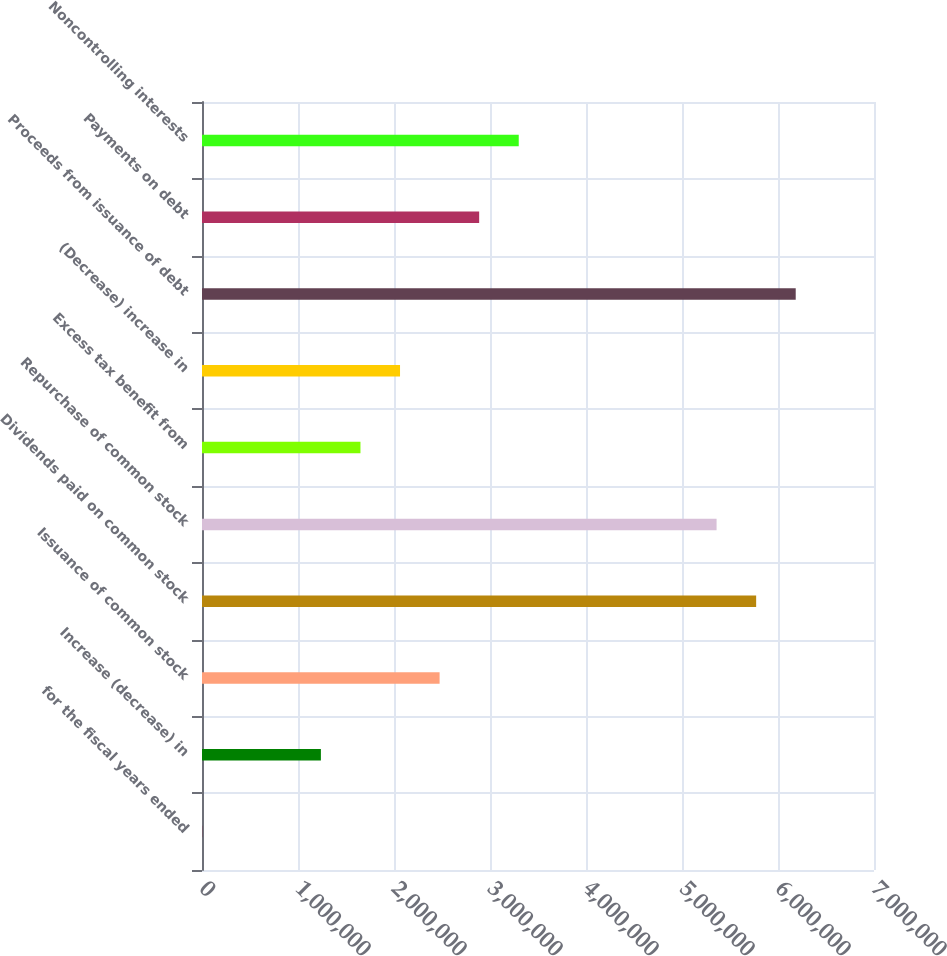<chart> <loc_0><loc_0><loc_500><loc_500><bar_chart><fcel>for the fiscal years ended<fcel>Increase (decrease) in<fcel>Issuance of common stock<fcel>Dividends paid on common stock<fcel>Repurchase of common stock<fcel>Excess tax benefit from<fcel>(Decrease) increase in<fcel>Proceeds from issuance of debt<fcel>Payments on debt<fcel>Noncontrolling interests<nl><fcel>2010<fcel>1.23852e+06<fcel>2.47503e+06<fcel>5.7724e+06<fcel>5.36023e+06<fcel>1.65069e+06<fcel>2.06286e+06<fcel>6.18457e+06<fcel>2.8872e+06<fcel>3.29937e+06<nl></chart> 